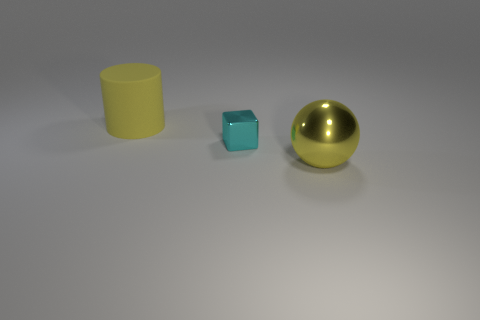Are there any other things that are made of the same material as the yellow cylinder?
Give a very brief answer. No. What is the size of the yellow thing in front of the big rubber cylinder?
Offer a terse response. Large. There is a shiny thing in front of the metal thing behind the yellow sphere; what color is it?
Keep it short and to the point. Yellow. What number of other objects are the same material as the cyan block?
Provide a succinct answer. 1. How many matte things are green balls or tiny blocks?
Your answer should be very brief. 0. What number of things are either tiny green cylinders or shiny blocks?
Offer a terse response. 1. The object that is the same material as the ball is what shape?
Provide a short and direct response. Cube. How many small objects are yellow metallic balls or yellow matte objects?
Your response must be concise. 0. How many other objects are the same color as the big shiny thing?
Your answer should be compact. 1. There is a rubber object left of the shiny thing that is behind the large yellow sphere; what number of large things are on the right side of it?
Make the answer very short. 1. 